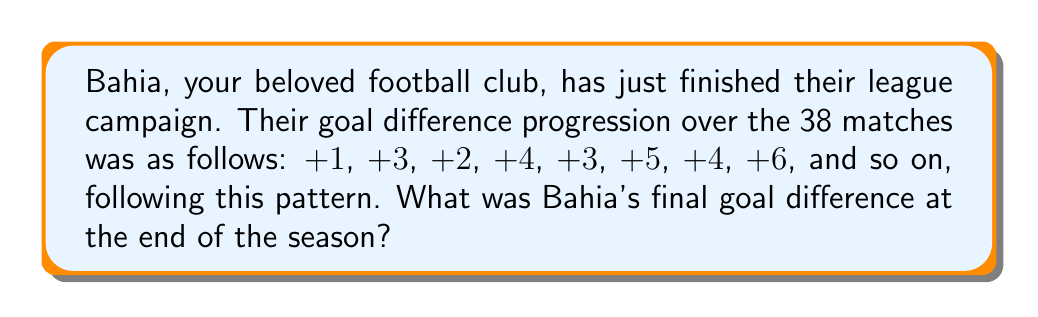Provide a solution to this math problem. Let's approach this step-by-step:

1) First, we need to identify the pattern in the goal difference progression:
   +1, +3, +2, +4, +3, +5, +4, +6, ...

2) We can see that it alternates between adding 2 and subtracting 1:
   +1, (+2) +3, (-1) +2, (+2) +4, (-1) +3, (+2) +5, (-1) +4, (+2) +6, ...

3) This forms a sequence where every odd-numbered term increases by 2, and every even-numbered term decreases by 1 from the previous odd term.

4) We can express this mathematically. Let $a_n$ be the nth term of the sequence:
   For odd n: $a_n = 2n - 1$
   For even n: $a_n = 2n - 2$

5) We need to find the 38th term of this sequence. Since 38 is even, we use the formula for even n:
   $a_{38} = 2(38) - 2 = 76 - 2 = 74$

6) However, this is not the final goal difference. We need to sum all terms from 1 to 38.

7) The sum of an arithmetic sequence is given by:
   $S_n = \frac{n(a_1 + a_n)}{2}$

8) In our case:
   $a_1 = 1$ (first term)
   $a_{38} = 74$ (last term)
   $n = 38$ (number of terms)

9) Plugging these into the formula:
   $S_{38} = \frac{38(1 + 74)}{2} = \frac{38 \times 75}{2} = 1425$

Therefore, Bahia's final goal difference at the end of the 38-match season was +1425.
Answer: +1425 